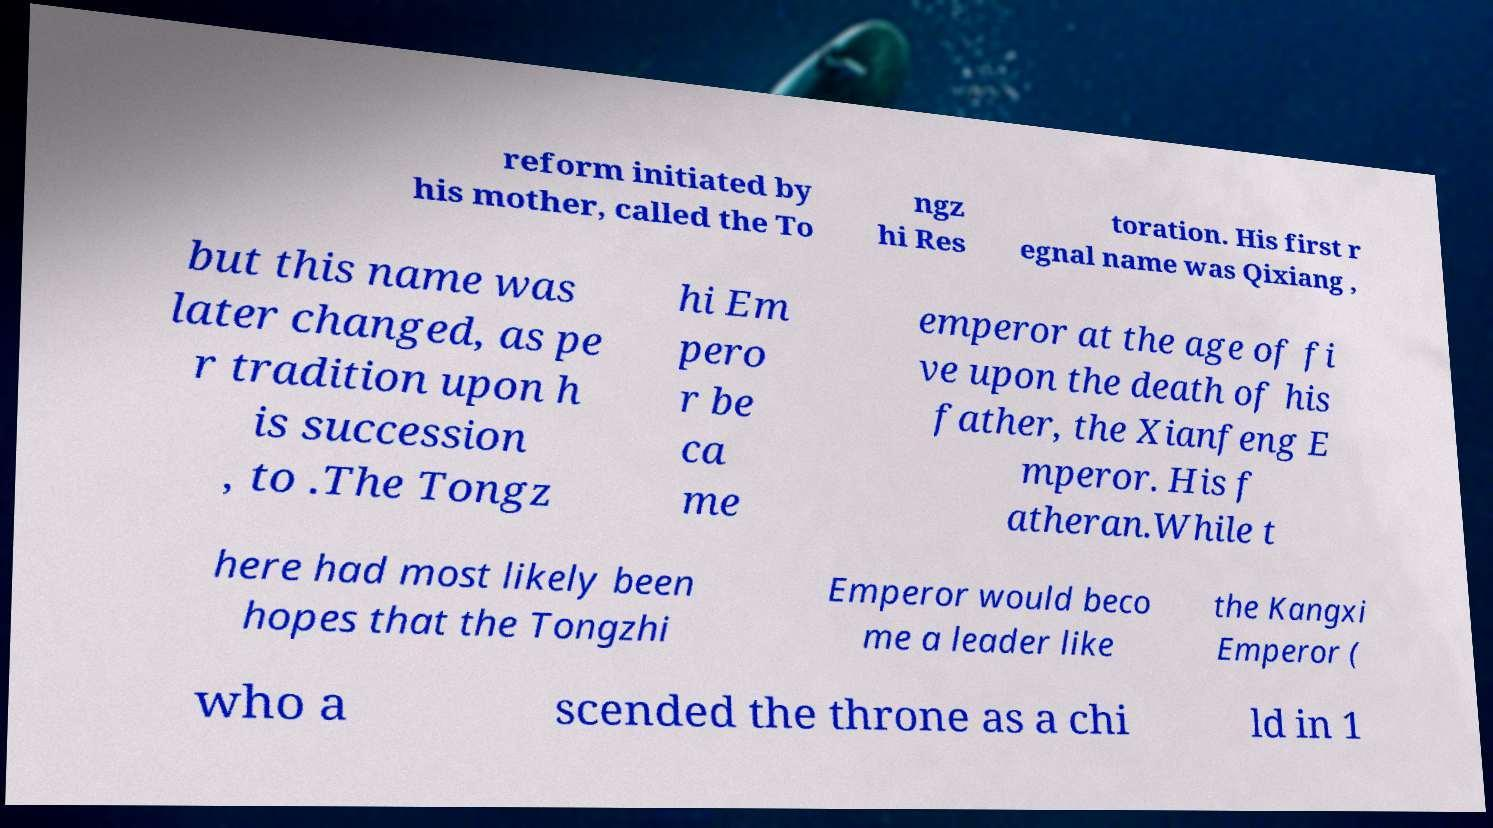Can you accurately transcribe the text from the provided image for me? reform initiated by his mother, called the To ngz hi Res toration. His first r egnal name was Qixiang , but this name was later changed, as pe r tradition upon h is succession , to .The Tongz hi Em pero r be ca me emperor at the age of fi ve upon the death of his father, the Xianfeng E mperor. His f atheran.While t here had most likely been hopes that the Tongzhi Emperor would beco me a leader like the Kangxi Emperor ( who a scended the throne as a chi ld in 1 